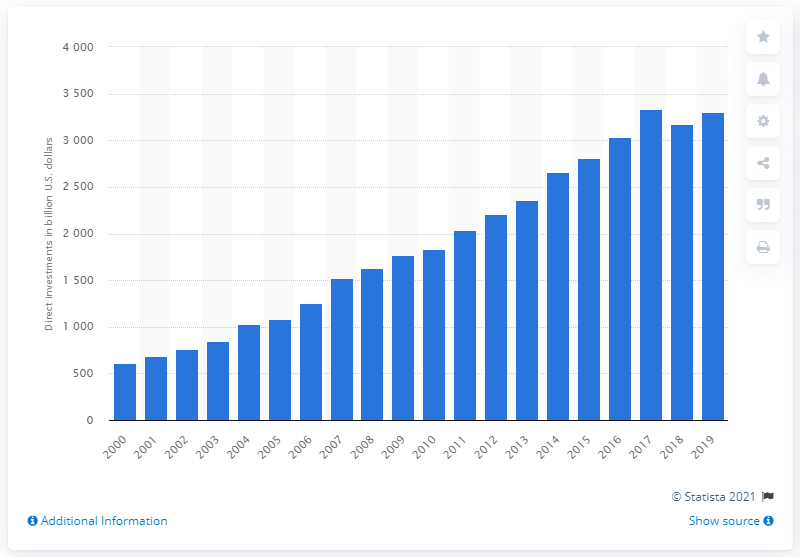How much did the United States direct investments in the EU total in dollars in 2019? In 2019, the United States direct investments in the European Union amounted to approximately 3.4 trillion dollars, showcasing a steady increase in economic engagement over the years. 